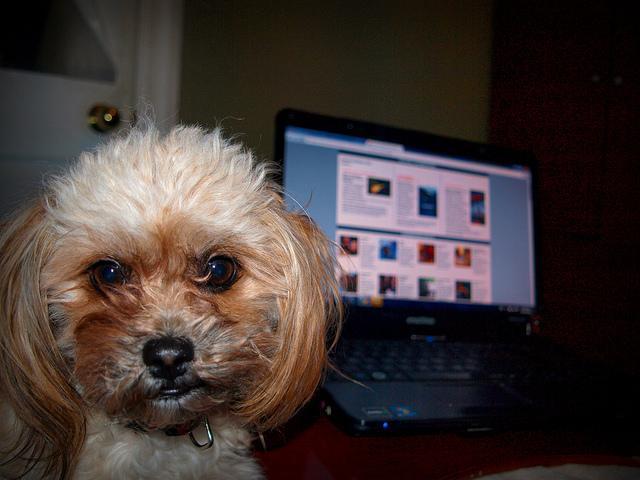How many dogs are there?
Give a very brief answer. 1. How many sinks are visible?
Give a very brief answer. 0. 